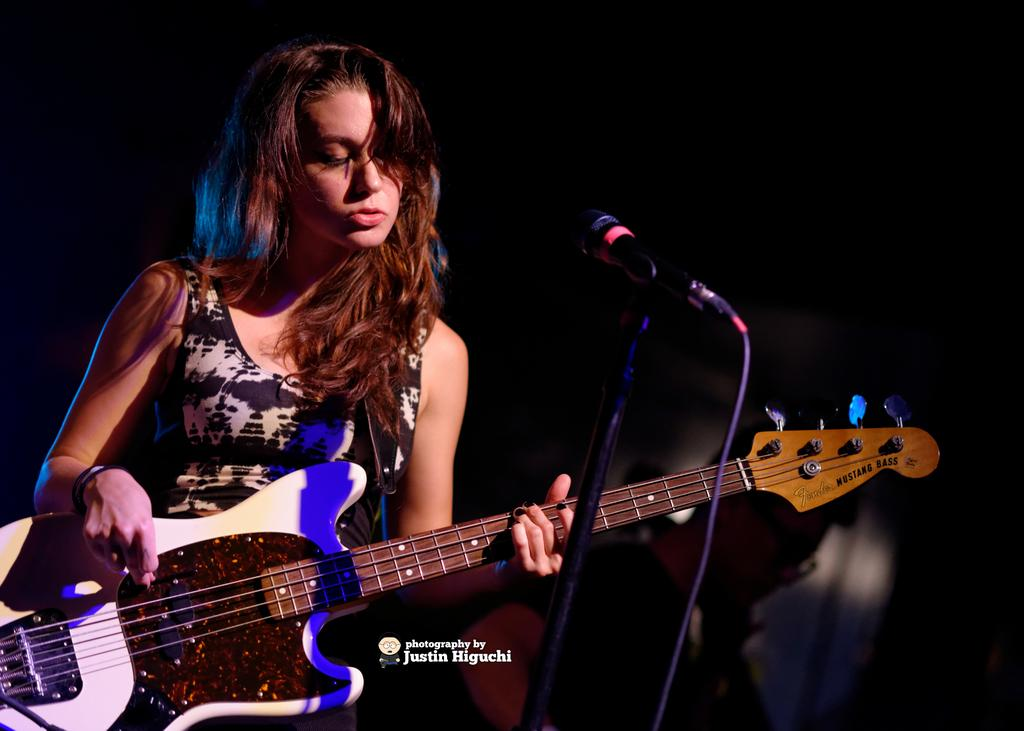What is the woman in the image doing? The woman is playing a guitar in the image. What object is present in the image that is typically used for amplifying sound? There is a microphone (mike) in the image. How many people are visible in the image? There is one person visible in the image, which is the woman playing the guitar. What type of insurance policy is the woman discussing with the bean in the image? There is no mention of insurance or a bean in the image; it features a woman playing a guitar and a microphone. 